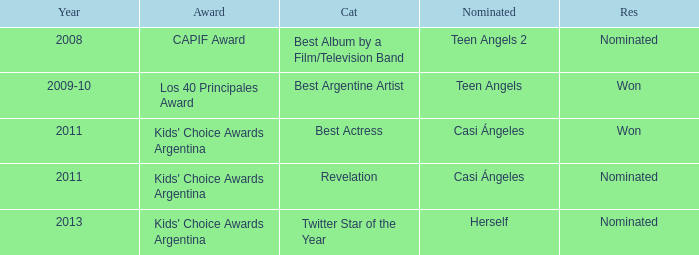In what category was Herself nominated? Twitter Star of the Year. 